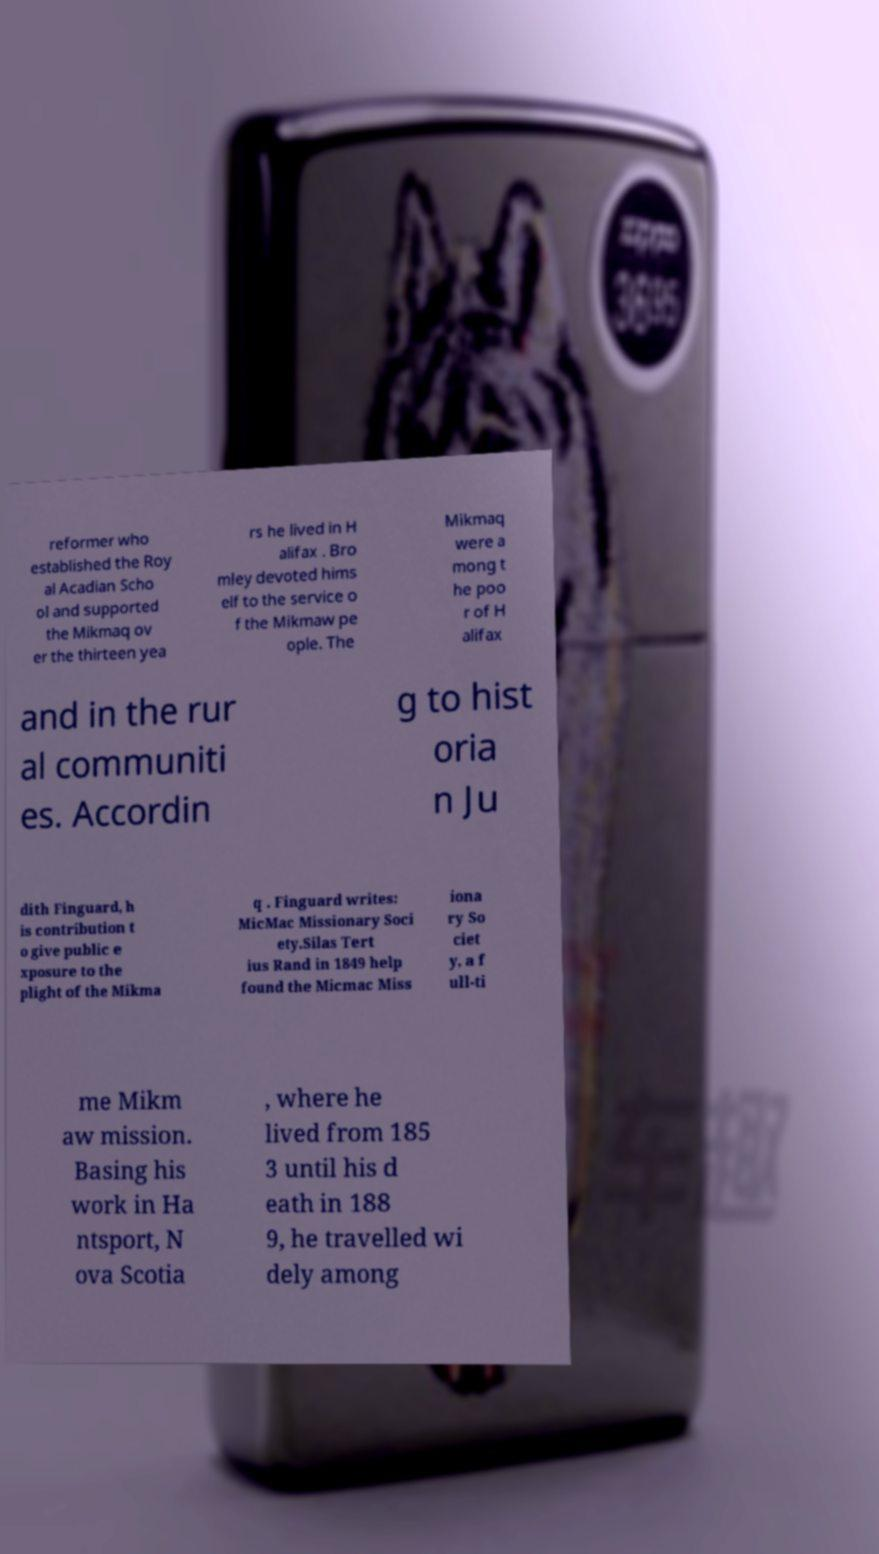What messages or text are displayed in this image? I need them in a readable, typed format. reformer who established the Roy al Acadian Scho ol and supported the Mikmaq ov er the thirteen yea rs he lived in H alifax . Bro mley devoted hims elf to the service o f the Mikmaw pe ople. The Mikmaq were a mong t he poo r of H alifax and in the rur al communiti es. Accordin g to hist oria n Ju dith Finguard, h is contribution t o give public e xposure to the plight of the Mikma q . Finguard writes: MicMac Missionary Soci ety.Silas Tert ius Rand in 1849 help found the Micmac Miss iona ry So ciet y, a f ull-ti me Mikm aw mission. Basing his work in Ha ntsport, N ova Scotia , where he lived from 185 3 until his d eath in 188 9, he travelled wi dely among 